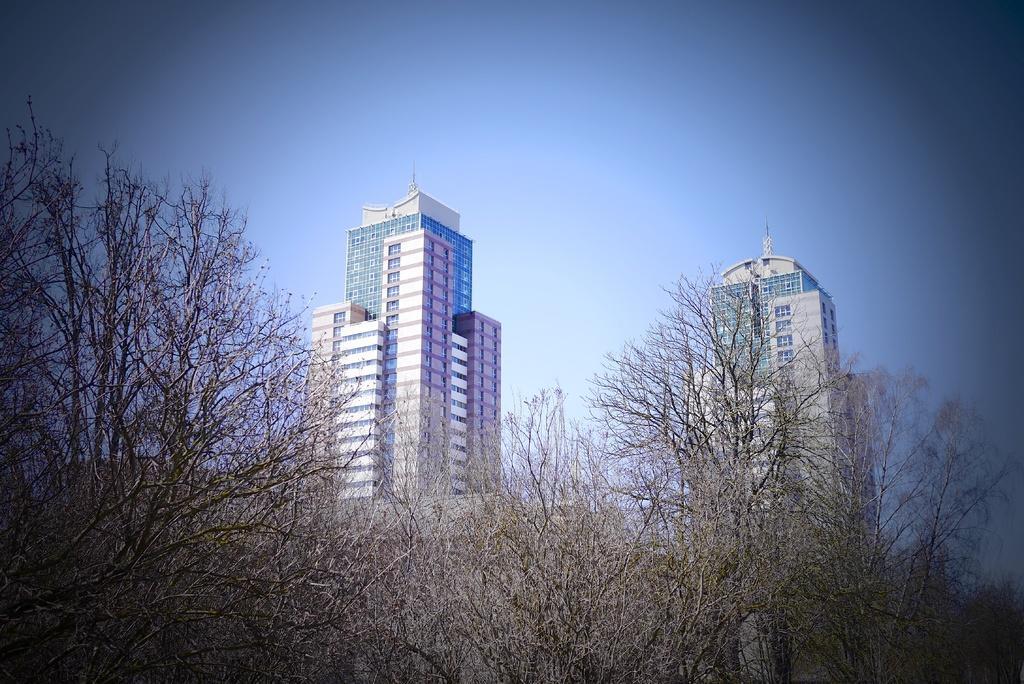Could you give a brief overview of what you see in this image? In the picture we can see some dried trees and behind it, we can see two tower buildings with windows and glasses to it and we can also see a sky which is blue in color. 